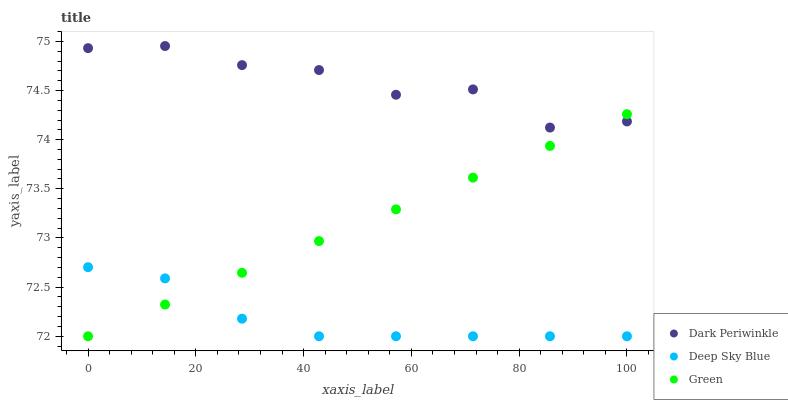Does Deep Sky Blue have the minimum area under the curve?
Answer yes or no. Yes. Does Dark Periwinkle have the maximum area under the curve?
Answer yes or no. Yes. Does Dark Periwinkle have the minimum area under the curve?
Answer yes or no. No. Does Deep Sky Blue have the maximum area under the curve?
Answer yes or no. No. Is Green the smoothest?
Answer yes or no. Yes. Is Dark Periwinkle the roughest?
Answer yes or no. Yes. Is Deep Sky Blue the smoothest?
Answer yes or no. No. Is Deep Sky Blue the roughest?
Answer yes or no. No. Does Green have the lowest value?
Answer yes or no. Yes. Does Dark Periwinkle have the lowest value?
Answer yes or no. No. Does Dark Periwinkle have the highest value?
Answer yes or no. Yes. Does Deep Sky Blue have the highest value?
Answer yes or no. No. Is Deep Sky Blue less than Dark Periwinkle?
Answer yes or no. Yes. Is Dark Periwinkle greater than Deep Sky Blue?
Answer yes or no. Yes. Does Deep Sky Blue intersect Green?
Answer yes or no. Yes. Is Deep Sky Blue less than Green?
Answer yes or no. No. Is Deep Sky Blue greater than Green?
Answer yes or no. No. Does Deep Sky Blue intersect Dark Periwinkle?
Answer yes or no. No. 